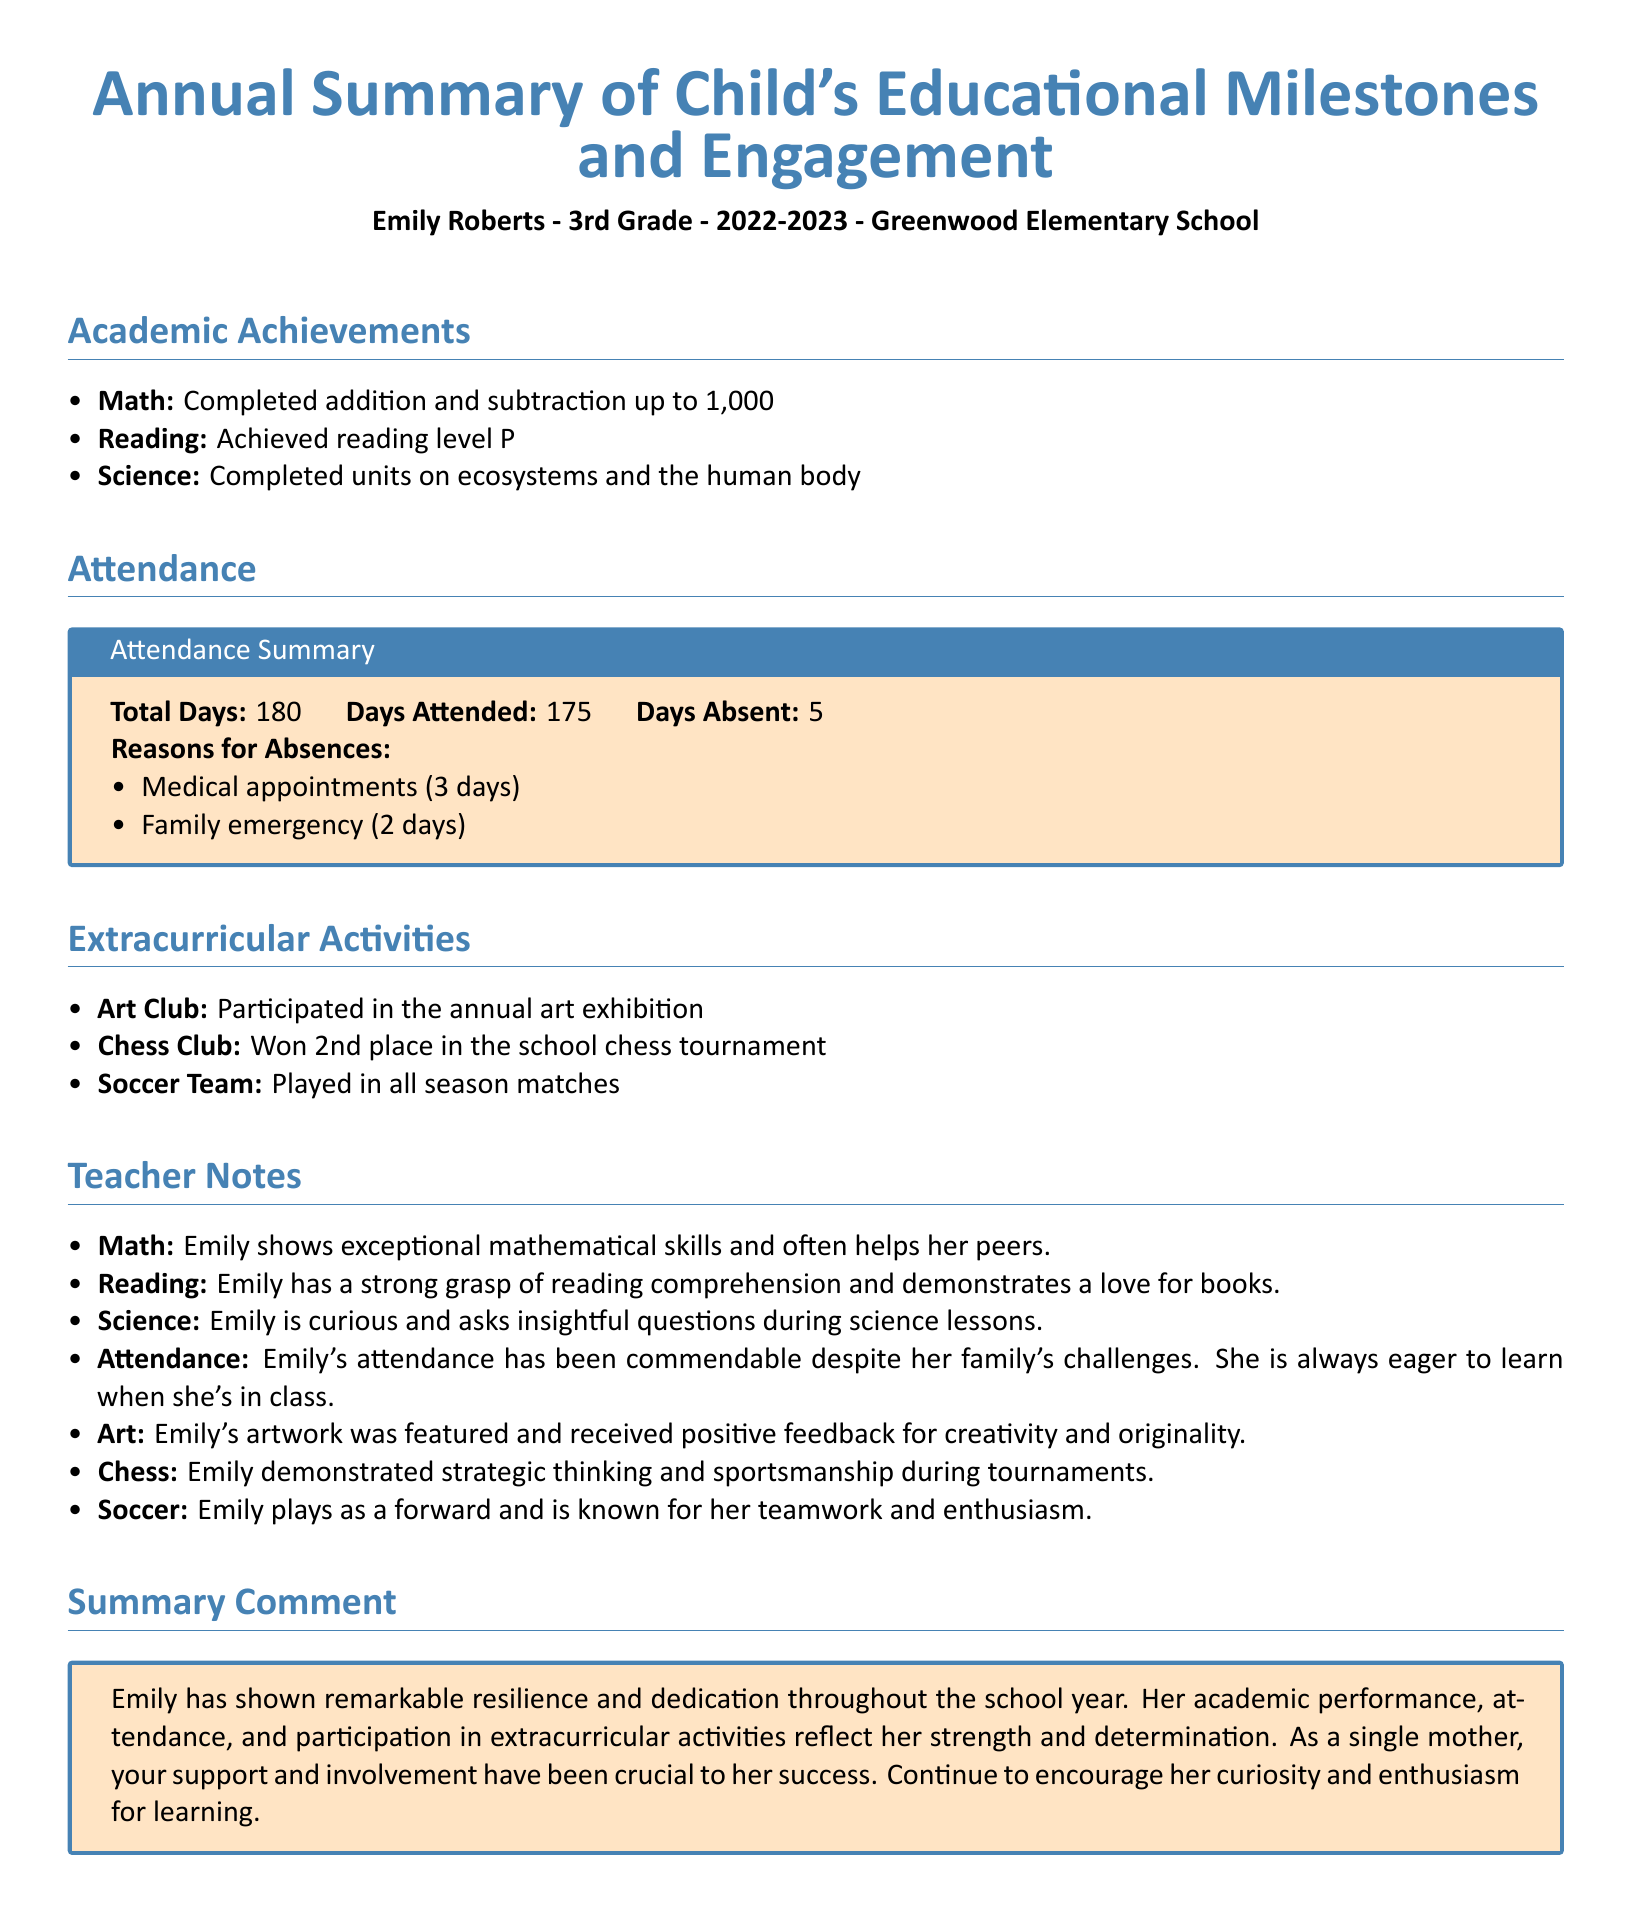what grade is Emily in? The document specifies that Emily is in 3rd Grade.
Answer: 3rd Grade how many days was Emily absent? The attendance section states that Emily was absent for 5 days.
Answer: 5 what achievements did Emily complete in Math? The academic achievements section lists that Emily completed addition and subtraction up to 1,000.
Answer: completed addition and subtraction up to 1,000 what place did Emily's team achieve in the chess tournament? The extracurricular activities section notes that Emily won 2nd place in the school chess tournament.
Answer: 2nd place how many total days did Emily attend school? The attendance summary shows that Emily attended school for 175 days out of 180 total days.
Answer: 175 what is mentioned about Emily's art participation? The document mentions that Emily participated in the annual art exhibition and received positive feedback.
Answer: participated in the annual art exhibition what skills does Emily demonstrate in her math class according to the teacher's notes? The teacher's notes indicate that Emily shows exceptional mathematical skills and often helps her peers.
Answer: exceptional mathematical skills how does the summary comment describe Emily's learning attitude? The summary comment emphasizes that Emily shows remarkable resilience and dedication throughout the school year.
Answer: remarkable resilience and dedication which sport does Emily play as a forward? The extracurricular activities section states that Emily plays soccer as a forward.
Answer: soccer 